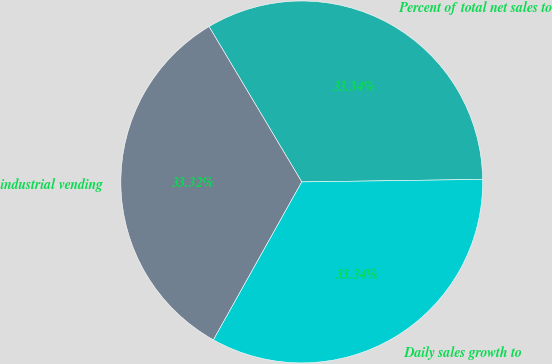<chart> <loc_0><loc_0><loc_500><loc_500><pie_chart><fcel>Percent of total net sales to<fcel>industrial vending<fcel>Daily sales growth to<nl><fcel>33.34%<fcel>33.32%<fcel>33.34%<nl></chart> 